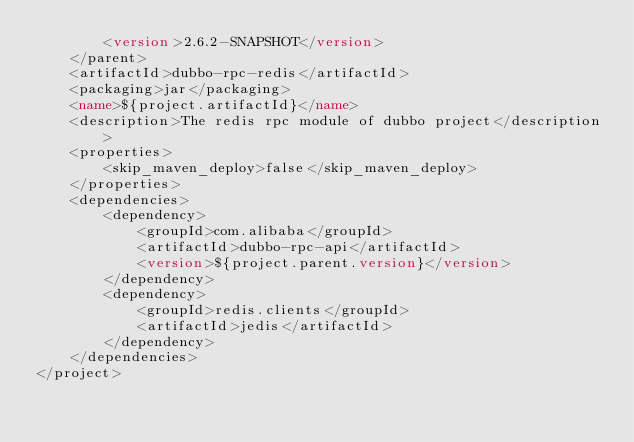<code> <loc_0><loc_0><loc_500><loc_500><_XML_>        <version>2.6.2-SNAPSHOT</version>
    </parent>
    <artifactId>dubbo-rpc-redis</artifactId>
    <packaging>jar</packaging>
    <name>${project.artifactId}</name>
    <description>The redis rpc module of dubbo project</description>
    <properties>
        <skip_maven_deploy>false</skip_maven_deploy>
    </properties>
    <dependencies>
        <dependency>
            <groupId>com.alibaba</groupId>
            <artifactId>dubbo-rpc-api</artifactId>
            <version>${project.parent.version}</version>
        </dependency>
        <dependency>
            <groupId>redis.clients</groupId>
            <artifactId>jedis</artifactId>
        </dependency>
    </dependencies>
</project></code> 